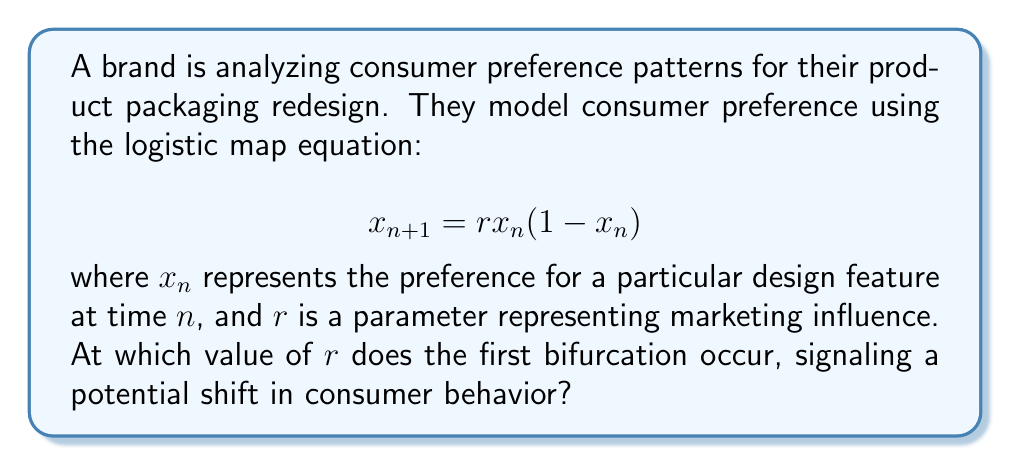Show me your answer to this math problem. To find the first bifurcation point in the logistic map, we need to follow these steps:

1) The logistic map has a fixed point when $x_{n+1} = x_n = x^*$. Substituting this into the equation:

   $$x^* = rx^*(1-x^*)$$

2) Solving this equation, we get two fixed points:
   
   $$x^* = 0$$ and $$x^* = 1 - \frac{1}{r}$$

3) The non-zero fixed point is stable when $|\frac{d}{dx}(rx(1-x))| < 1$ at $x = 1 - \frac{1}{r}$:

   $$|\frac{d}{dx}(rx(1-x))| = |r(1-2x)| < 1$$

4) Substituting $x = 1 - \frac{1}{r}$:

   $$|r(1-2(1-\frac{1}{r}))| = |r(-1+\frac{2}{r})| = |-r+2| < 1$$

5) Solving this inequality:
   
   $$-1 < -r+2 < 1$$
   $$1 < r < 3$$

6) The first bifurcation occurs when the non-zero fixed point becomes unstable, which is at the upper bound of this inequality:

   $$r = 3$$

This is the point where consumer preferences may start to oscillate between two values, indicating a potential shift in behavior.
Answer: $r = 3$ 